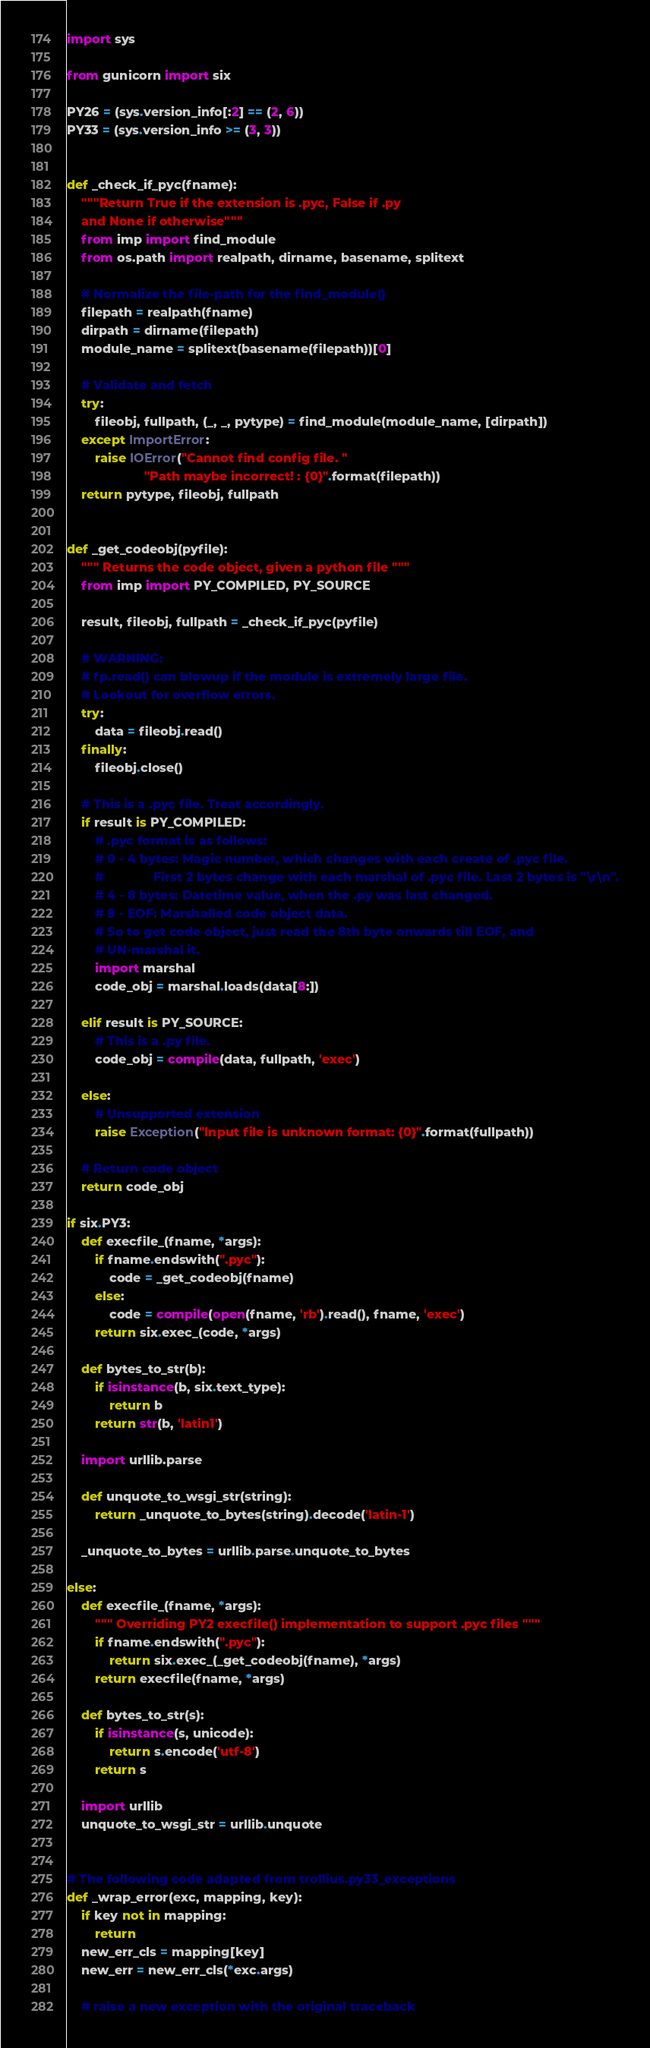Convert code to text. <code><loc_0><loc_0><loc_500><loc_500><_Python_>import sys

from gunicorn import six

PY26 = (sys.version_info[:2] == (2, 6))
PY33 = (sys.version_info >= (3, 3))


def _check_if_pyc(fname):
    """Return True if the extension is .pyc, False if .py
    and None if otherwise"""
    from imp import find_module
    from os.path import realpath, dirname, basename, splitext

    # Normalize the file-path for the find_module()
    filepath = realpath(fname)
    dirpath = dirname(filepath)
    module_name = splitext(basename(filepath))[0]

    # Validate and fetch
    try:
        fileobj, fullpath, (_, _, pytype) = find_module(module_name, [dirpath])
    except ImportError:
        raise IOError("Cannot find config file. "
                      "Path maybe incorrect! : {0}".format(filepath))
    return pytype, fileobj, fullpath


def _get_codeobj(pyfile):
    """ Returns the code object, given a python file """
    from imp import PY_COMPILED, PY_SOURCE

    result, fileobj, fullpath = _check_if_pyc(pyfile)

    # WARNING:
    # fp.read() can blowup if the module is extremely large file.
    # Lookout for overflow errors.
    try:
        data = fileobj.read()
    finally:
        fileobj.close()

    # This is a .pyc file. Treat accordingly.
    if result is PY_COMPILED:
        # .pyc format is as follows:
        # 0 - 4 bytes: Magic number, which changes with each create of .pyc file.
        #              First 2 bytes change with each marshal of .pyc file. Last 2 bytes is "\r\n".
        # 4 - 8 bytes: Datetime value, when the .py was last changed.
        # 8 - EOF: Marshalled code object data.
        # So to get code object, just read the 8th byte onwards till EOF, and
        # UN-marshal it.
        import marshal
        code_obj = marshal.loads(data[8:])

    elif result is PY_SOURCE:
        # This is a .py file.
        code_obj = compile(data, fullpath, 'exec')

    else:
        # Unsupported extension
        raise Exception("Input file is unknown format: {0}".format(fullpath))

    # Return code object
    return code_obj

if six.PY3:
    def execfile_(fname, *args):
        if fname.endswith(".pyc"):
            code = _get_codeobj(fname)
        else:
            code = compile(open(fname, 'rb').read(), fname, 'exec')
        return six.exec_(code, *args)

    def bytes_to_str(b):
        if isinstance(b, six.text_type):
            return b
        return str(b, 'latin1')

    import urllib.parse

    def unquote_to_wsgi_str(string):
        return _unquote_to_bytes(string).decode('latin-1')

    _unquote_to_bytes = urllib.parse.unquote_to_bytes

else:
    def execfile_(fname, *args):
        """ Overriding PY2 execfile() implementation to support .pyc files """
        if fname.endswith(".pyc"):
            return six.exec_(_get_codeobj(fname), *args)
        return execfile(fname, *args)

    def bytes_to_str(s):
        if isinstance(s, unicode):
            return s.encode('utf-8')
        return s

    import urllib
    unquote_to_wsgi_str = urllib.unquote


# The following code adapted from trollius.py33_exceptions
def _wrap_error(exc, mapping, key):
    if key not in mapping:
        return
    new_err_cls = mapping[key]
    new_err = new_err_cls(*exc.args)

    # raise a new exception with the original traceback</code> 